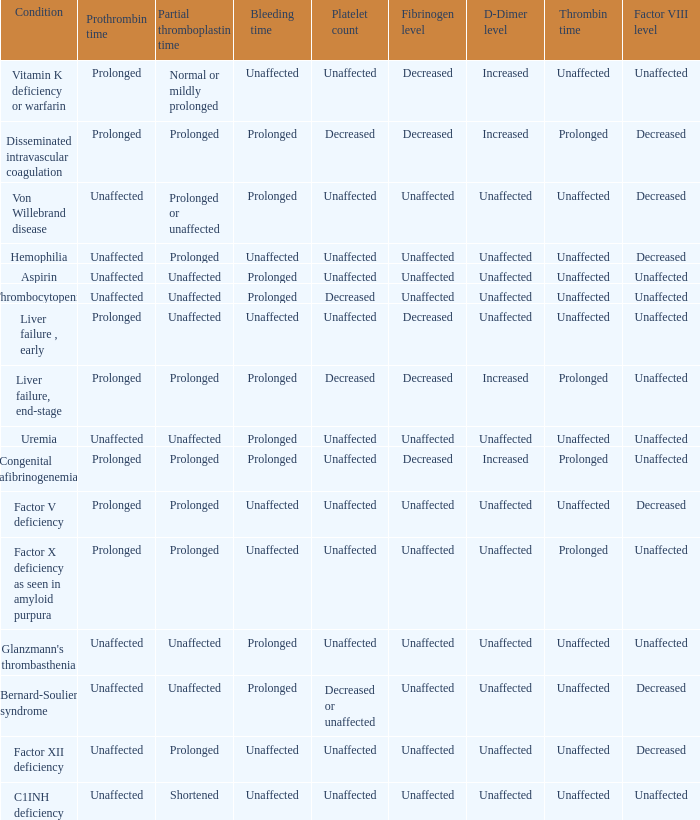Which Platelet count has a Condition of bernard-soulier syndrome? Decreased or unaffected. 